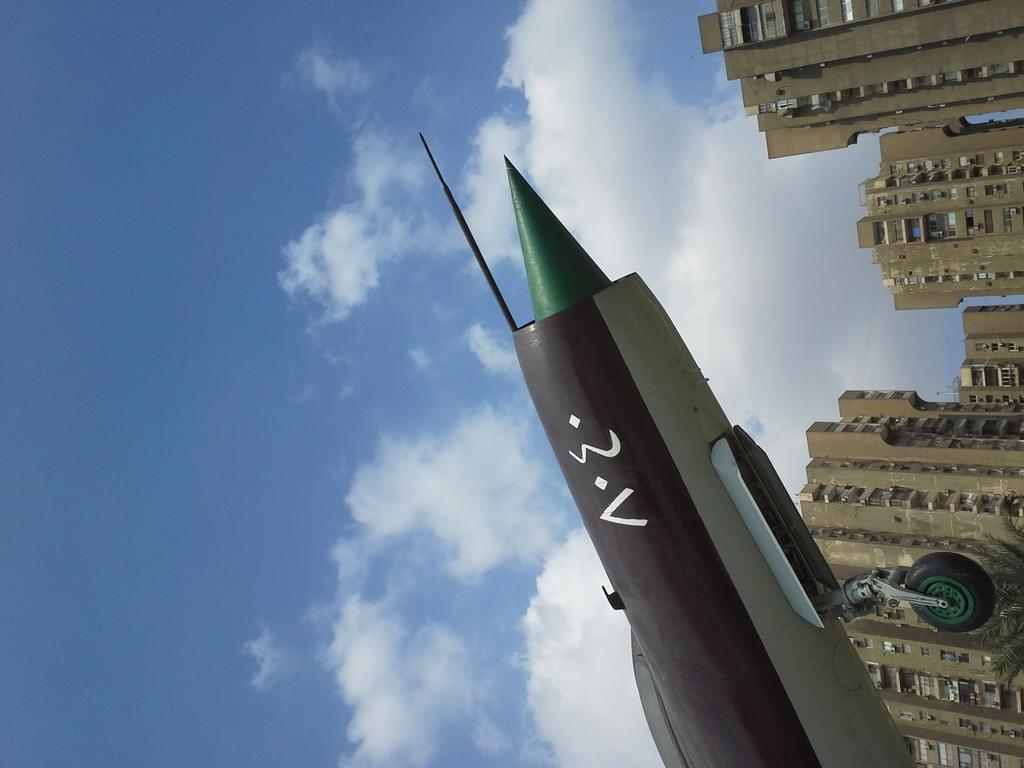What is visible in the background of the image? Sky is visible in the image. What can be seen in the sky in the image? There are clouds in the image. What type of structures are present in the image? There are buildings in the image. What is the main subject of the image? There is an airplane in the image. What type of thought can be seen floating in the sky in the image? There are no thoughts visible in the image; only clouds and an airplane are present. What type of fuel is being used by the fog in the image? There is no fog present in the image, and therefore no fuel can be associated with it. 